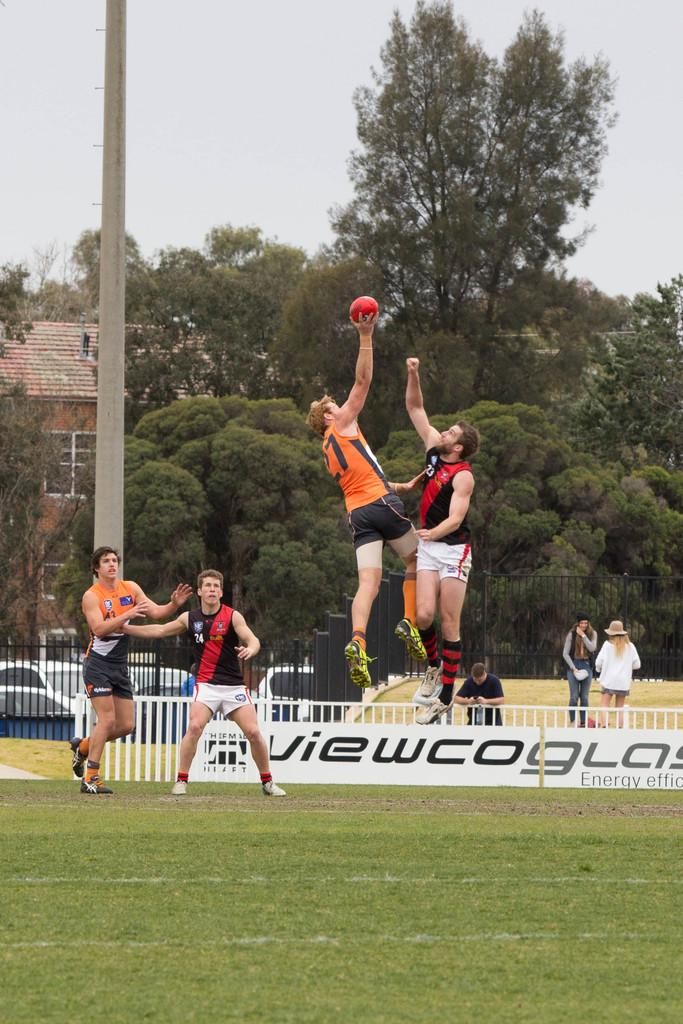<image>
Present a compact description of the photo's key features. Four men playing rugby in a match sponsored by Viewcoglas 